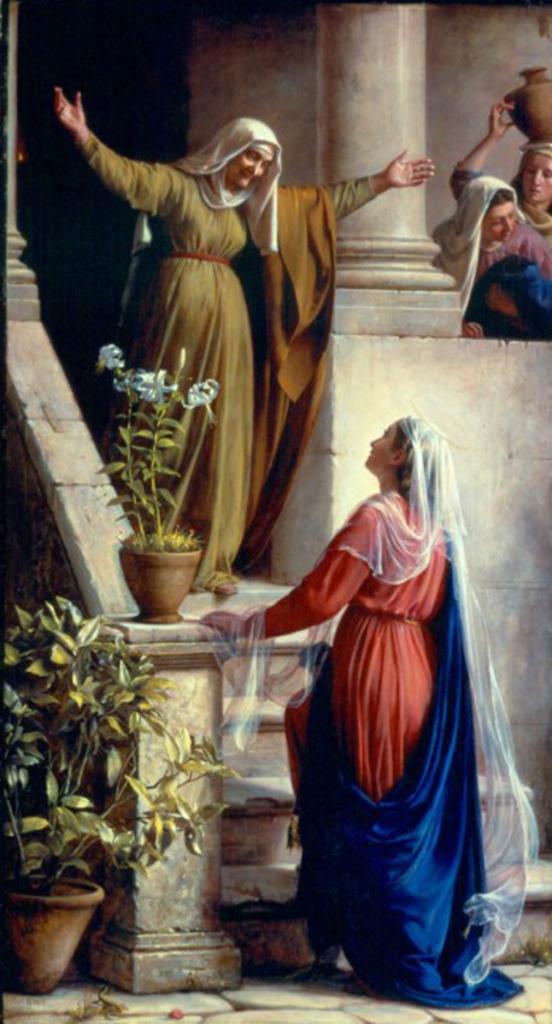Can you describe this image briefly? In this picture we can see four women standing, house plants, steps, pillar and in the background we can see wall. 